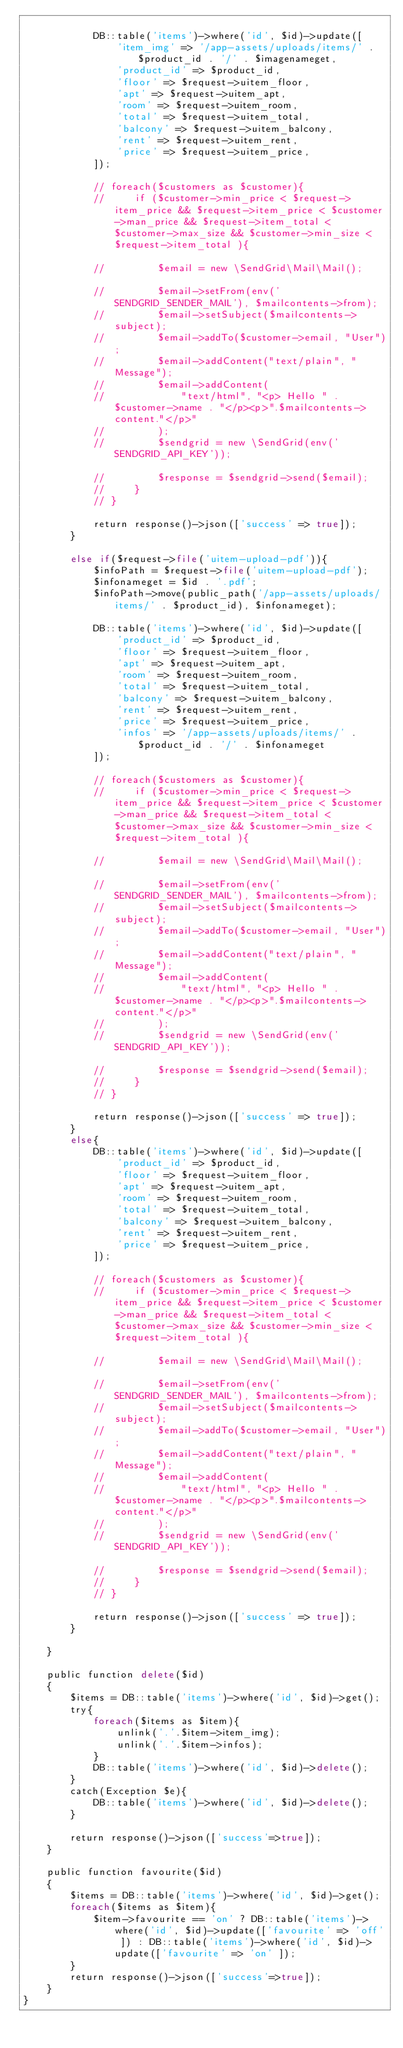<code> <loc_0><loc_0><loc_500><loc_500><_PHP_>
            DB::table('items')->where('id', $id)->update([
                'item_img' => '/app-assets/uploads/items/' . $product_id . '/' . $imagenameget,
                'product_id' => $product_id,
                'floor' => $request->uitem_floor,
                'apt' => $request->uitem_apt,
                'room' => $request->uitem_room,
                'total' => $request->uitem_total,
                'balcony' => $request->uitem_balcony,
                'rent' => $request->uitem_rent,
                'price' => $request->uitem_price,
            ]);

            // foreach($customers as $customer){
            //     if ($customer->min_price < $request->item_price && $request->item_price < $customer->man_price && $request->item_total < $customer->max_size && $customer->min_size < $request->item_total ){
    
            //         $email = new \SendGrid\Mail\Mail();
    
            //         $email->setFrom(env('SENDGRID_SENDER_MAIL'), $mailcontents->from);
            //         $email->setSubject($mailcontents->subject);
            //         $email->addTo($customer->email, "User");
            //         $email->addContent("text/plain", "Message");
            //         $email->addContent(
            //             "text/html", "<p> Hello " . $customer->name . "</p><p>".$mailcontents->content."</p>"
            //         );
            //         $sendgrid = new \SendGrid(env('SENDGRID_API_KEY'));
    
            //         $response = $sendgrid->send($email);
            //     }
            // }

            return response()->json(['success' => true]);
        }

        else if($request->file('uitem-upload-pdf')){
            $infoPath = $request->file('uitem-upload-pdf');
            $infonameget = $id . '.pdf';
            $infoPath->move(public_path('/app-assets/uploads/items/' . $product_id), $infonameget);

            DB::table('items')->where('id', $id)->update([
                'product_id' => $product_id,
                'floor' => $request->uitem_floor,
                'apt' => $request->uitem_apt,
                'room' => $request->uitem_room,
                'total' => $request->uitem_total,
                'balcony' => $request->uitem_balcony,
                'rent' => $request->uitem_rent,
                'price' => $request->uitem_price,
                'infos' => '/app-assets/uploads/items/' . $product_id . '/' . $infonameget
            ]);

            // foreach($customers as $customer){
            //     if ($customer->min_price < $request->item_price && $request->item_price < $customer->man_price && $request->item_total < $customer->max_size && $customer->min_size < $request->item_total ){
    
            //         $email = new \SendGrid\Mail\Mail();
    
            //         $email->setFrom(env('SENDGRID_SENDER_MAIL'), $mailcontents->from);
            //         $email->setSubject($mailcontents->subject);
            //         $email->addTo($customer->email, "User");
            //         $email->addContent("text/plain", "Message");
            //         $email->addContent(
            //             "text/html", "<p> Hello " . $customer->name . "</p><p>".$mailcontents->content."</p>"
            //         );
            //         $sendgrid = new \SendGrid(env('SENDGRID_API_KEY'));
    
            //         $response = $sendgrid->send($email);
            //     }
            // }

            return response()->json(['success' => true]);
        }
        else{
            DB::table('items')->where('id', $id)->update([
                'product_id' => $product_id,
                'floor' => $request->uitem_floor,
                'apt' => $request->uitem_apt,
                'room' => $request->uitem_room,
                'total' => $request->uitem_total,
                'balcony' => $request->uitem_balcony,
                'rent' => $request->uitem_rent,
                'price' => $request->uitem_price,
            ]);

            // foreach($customers as $customer){
            //     if ($customer->min_price < $request->item_price && $request->item_price < $customer->man_price && $request->item_total < $customer->max_size && $customer->min_size < $request->item_total ){
    
            //         $email = new \SendGrid\Mail\Mail();
    
            //         $email->setFrom(env('SENDGRID_SENDER_MAIL'), $mailcontents->from);
            //         $email->setSubject($mailcontents->subject);
            //         $email->addTo($customer->email, "User");
            //         $email->addContent("text/plain", "Message");
            //         $email->addContent(
            //             "text/html", "<p> Hello " . $customer->name . "</p><p>".$mailcontents->content."</p>"
            //         );
            //         $sendgrid = new \SendGrid(env('SENDGRID_API_KEY'));
    
            //         $response = $sendgrid->send($email);
            //     }
            // }

            return response()->json(['success' => true]);
        }

    }

    public function delete($id)
    {
        $items = DB::table('items')->where('id', $id)->get();
        try{
            foreach($items as $item){
                unlink('.'.$item->item_img);
                unlink('.'.$item->infos);
            }
            DB::table('items')->where('id', $id)->delete();
        }
        catch(Exception $e){
            DB::table('items')->where('id', $id)->delete();
        }
        
        return response()->json(['success'=>true]);
    }

    public function favourite($id)
    {
        $items = DB::table('items')->where('id', $id)->get();
        foreach($items as $item){
            $item->favourite == 'on' ? DB::table('items')->where('id', $id)->update(['favourite' => 'off' ]) : DB::table('items')->where('id', $id)->update(['favourite' => 'on' ]);
        }
        return response()->json(['success'=>true]);
    }
}
</code> 